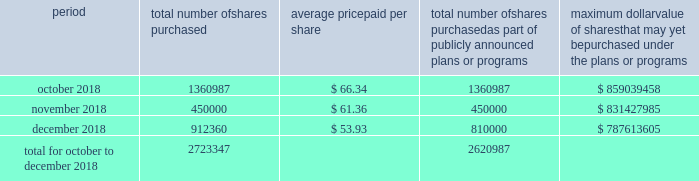Table of content part ii item 5 .
Market for the registrant's common equity , related stockholder matters and issuer purchases of equity securities our common stock is traded on the new york stock exchange under the trading symbol 201chfc . 201d in september 2018 , our board of directors approved a $ 1 billion share repurchase program , which replaced all existing share repurchase programs , authorizing us to repurchase common stock in the open market or through privately negotiated transactions .
The timing and amount of stock repurchases will depend on market conditions and corporate , regulatory and other relevant considerations .
This program may be discontinued at any time by the board of directors .
The table includes repurchases made under this program during the fourth quarter of 2018 .
Period total number of shares purchased average price paid per share total number of shares purchased as part of publicly announced plans or programs maximum dollar value of shares that may yet be purchased under the plans or programs .
During the quarter ended december 31 , 2018 , 102360 shares were withheld from certain executives and employees under the terms of our share-based compensation agreements to provide funds for the payment of payroll and income taxes due at vesting of restricted stock awards .
As of february 13 , 2019 , we had approximately 97419 stockholders , including beneficial owners holding shares in street name .
We intend to consider the declaration of a dividend on a quarterly basis , although there is no assurance as to future dividends since they are dependent upon future earnings , capital requirements , our financial condition and other factors. .
Of total repurchases in october to december 2018 , what percentage of shares purchased were part of publicly announced plans or programs? 
Computations: (2620987 / 2723347)
Answer: 0.96241. 